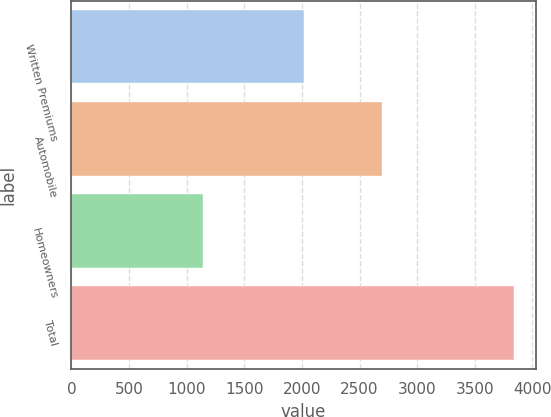Convert chart to OTSL. <chart><loc_0><loc_0><loc_500><loc_500><bar_chart><fcel>Written Premiums<fcel>Automobile<fcel>Homeowners<fcel>Total<nl><fcel>2016<fcel>2694<fcel>1143<fcel>3837<nl></chart> 